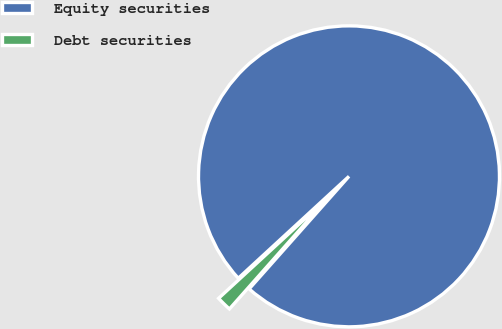Convert chart to OTSL. <chart><loc_0><loc_0><loc_500><loc_500><pie_chart><fcel>Equity securities<fcel>Debt securities<nl><fcel>98.39%<fcel>1.61%<nl></chart> 